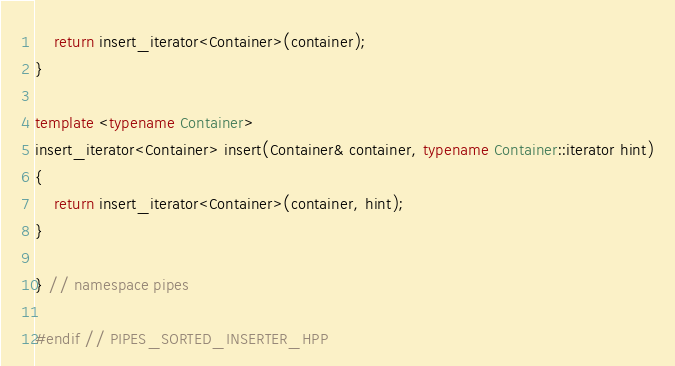Convert code to text. <code><loc_0><loc_0><loc_500><loc_500><_C++_>    return insert_iterator<Container>(container);
}

template <typename Container>
insert_iterator<Container> insert(Container& container, typename Container::iterator hint)
{
    return insert_iterator<Container>(container, hint);
}

} // namespace pipes

#endif // PIPES_SORTED_INSERTER_HPP
</code> 